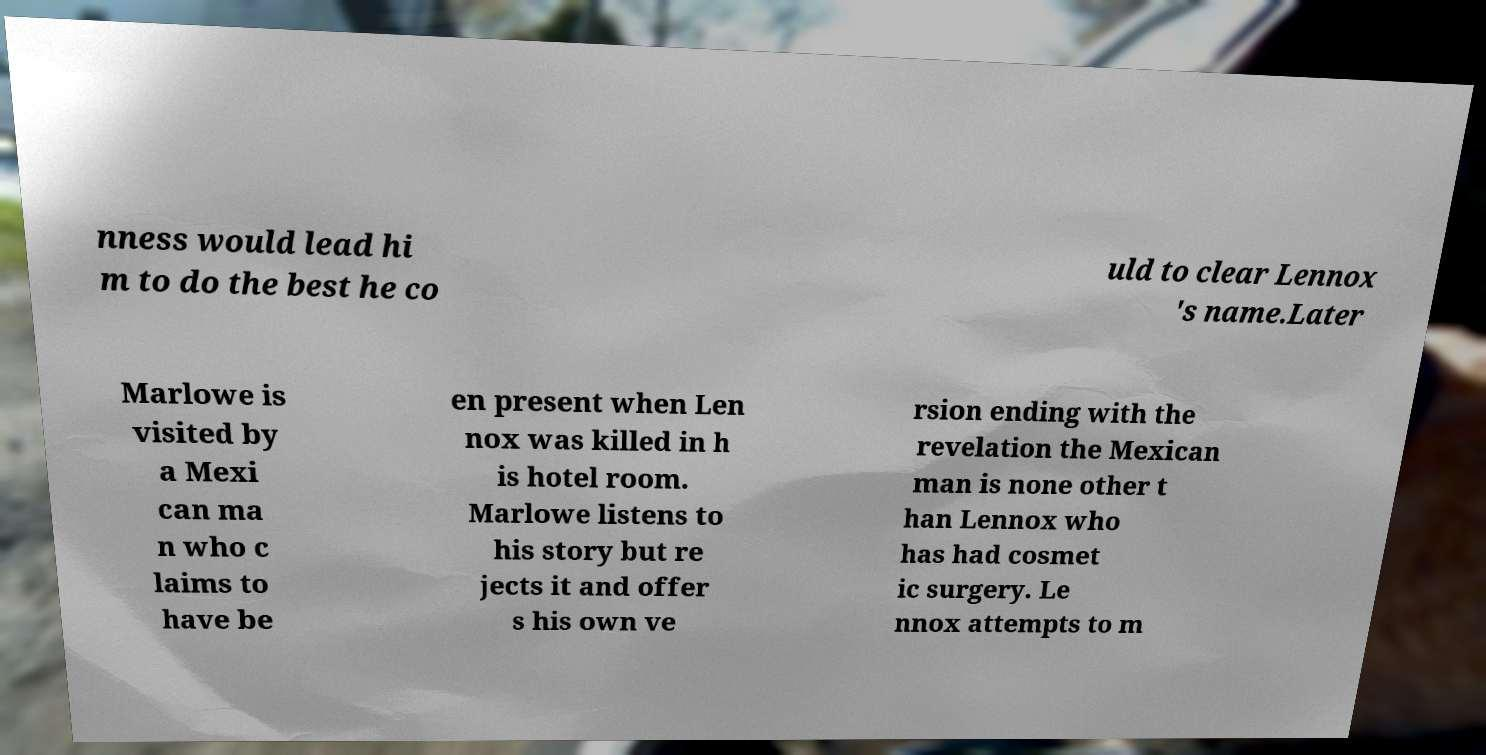I need the written content from this picture converted into text. Can you do that? nness would lead hi m to do the best he co uld to clear Lennox 's name.Later Marlowe is visited by a Mexi can ma n who c laims to have be en present when Len nox was killed in h is hotel room. Marlowe listens to his story but re jects it and offer s his own ve rsion ending with the revelation the Mexican man is none other t han Lennox who has had cosmet ic surgery. Le nnox attempts to m 